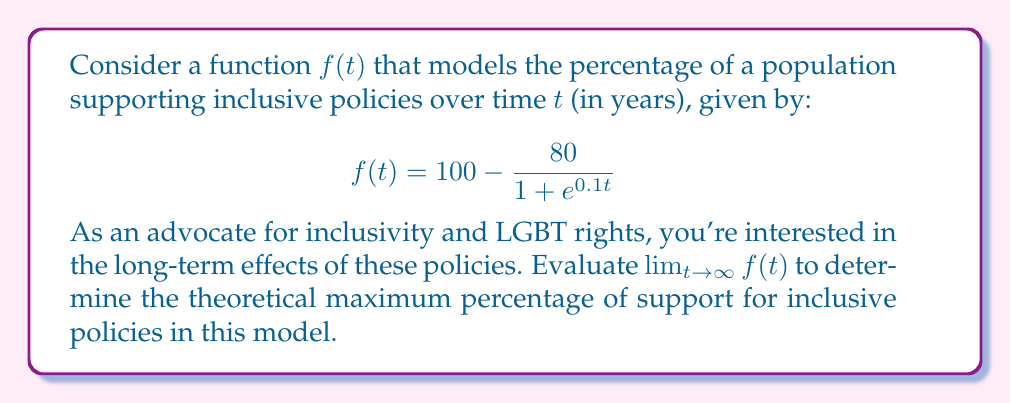Can you solve this math problem? To evaluate this limit, let's follow these steps:

1) First, let's consider the behavior of the fraction $\frac{80}{1 + e^{0.1t}}$ as $t$ approaches infinity.

2) As $t \to \infty$, $e^{0.1t} \to \infty$ because the exponential function grows faster than any polynomial.

3) Therefore, as $t \to \infty$:

   $$\lim_{t \to \infty} \frac{80}{1 + e^{0.1t}} = \frac{80}{\infty} = 0$$

4) Now, let's apply this to our original function:

   $$\lim_{t \to \infty} f(t) = \lim_{t \to \infty} \left(100 - \frac{80}{1 + e^{0.1t}}\right)$$

5) We can split this limit:

   $$\lim_{t \to \infty} f(t) = \lim_{t \to \infty} 100 - \lim_{t \to \infty} \frac{80}{1 + e^{0.1t}}$$

6) From step 3, we know that the second limit is 0, so:

   $$\lim_{t \to \infty} f(t) = 100 - 0 = 100$$

This result suggests that in the long term, the model predicts that support for inclusive policies could theoretically reach 100% of the population.
Answer: $$\lim_{t \to \infty} f(t) = 100$$ 